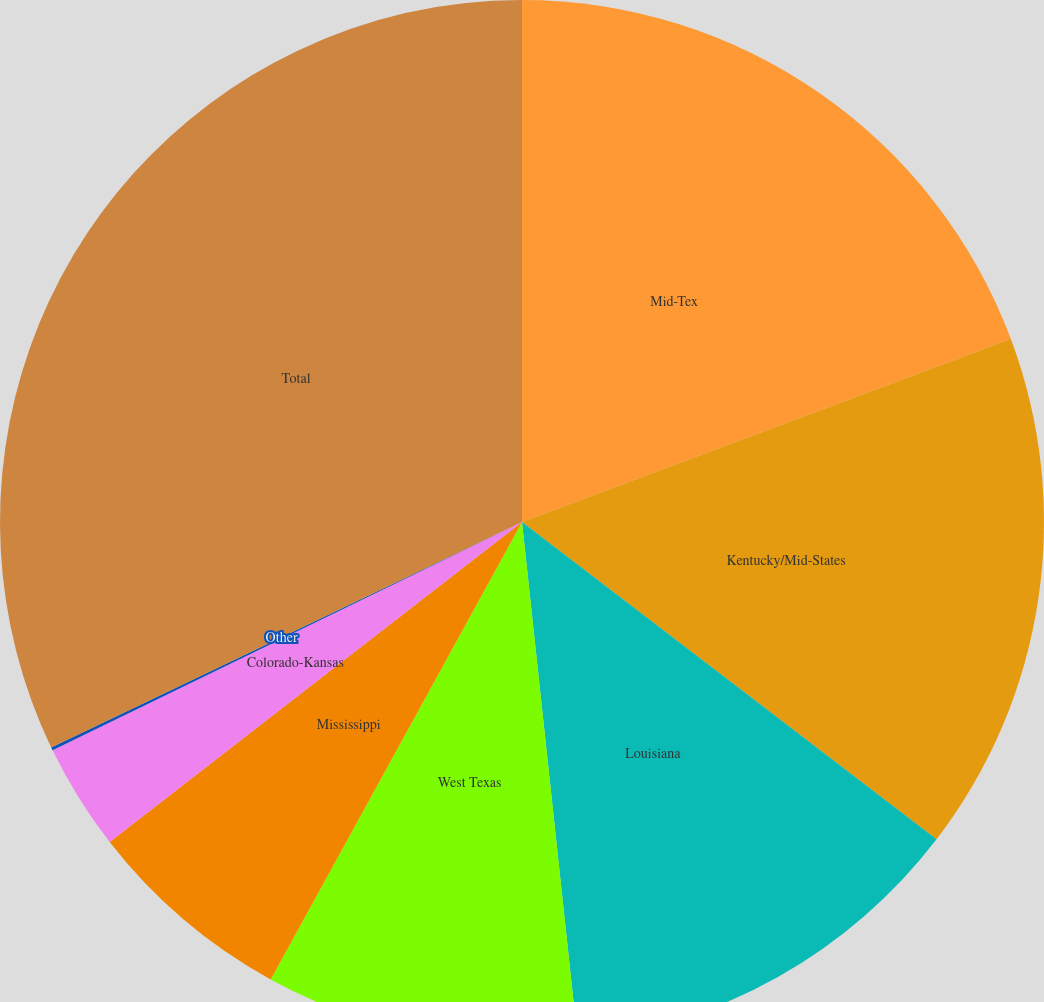Convert chart to OTSL. <chart><loc_0><loc_0><loc_500><loc_500><pie_chart><fcel>Mid-Tex<fcel>Kentucky/Mid-States<fcel>Louisiana<fcel>West Texas<fcel>Mississippi<fcel>Colorado-Kansas<fcel>Other<fcel>Total<nl><fcel>19.3%<fcel>16.1%<fcel>12.9%<fcel>9.7%<fcel>6.5%<fcel>3.3%<fcel>0.1%<fcel>32.11%<nl></chart> 